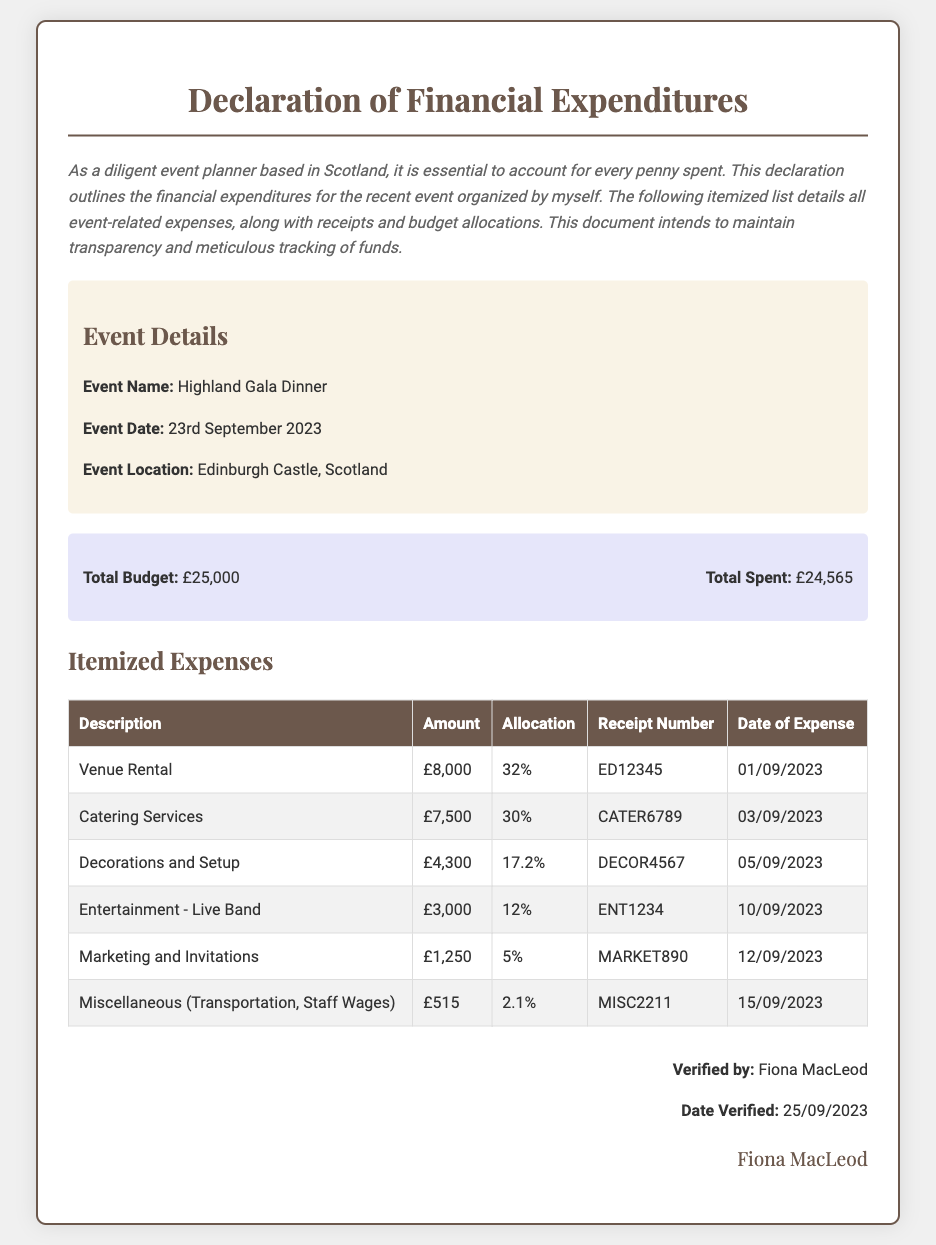What is the event name? The event name is clearly stated in the document.
Answer: Highland Gala Dinner What is the total budget? The total budget can be found in the expense summary section of the document.
Answer: £25,000 What percentage was allocated for catering services? The allocation for catering services is specified in the itemized expenses section.
Answer: 30% What was the date of expense for decorations and setup? The date of expense for decorations and setup is mentioned in the itemized expenses table.
Answer: 05/09/2023 How much was spent on the live band? The amount spent on the live band is listed in the itemized expenses table.
Answer: £3,000 What is the total spent amount? The total spent amount is provided in the expense summary section.
Answer: £24,565 Who verified the document? The name of the person who verified the document is indicated at the end of the document.
Answer: Fiona MacLeod What date was the document verified? The date verified information is included in the verification section.
Answer: 25/09/2023 What type of document is this? The title of the document indicates its purpose.
Answer: Declaration of Financial Expenditures 